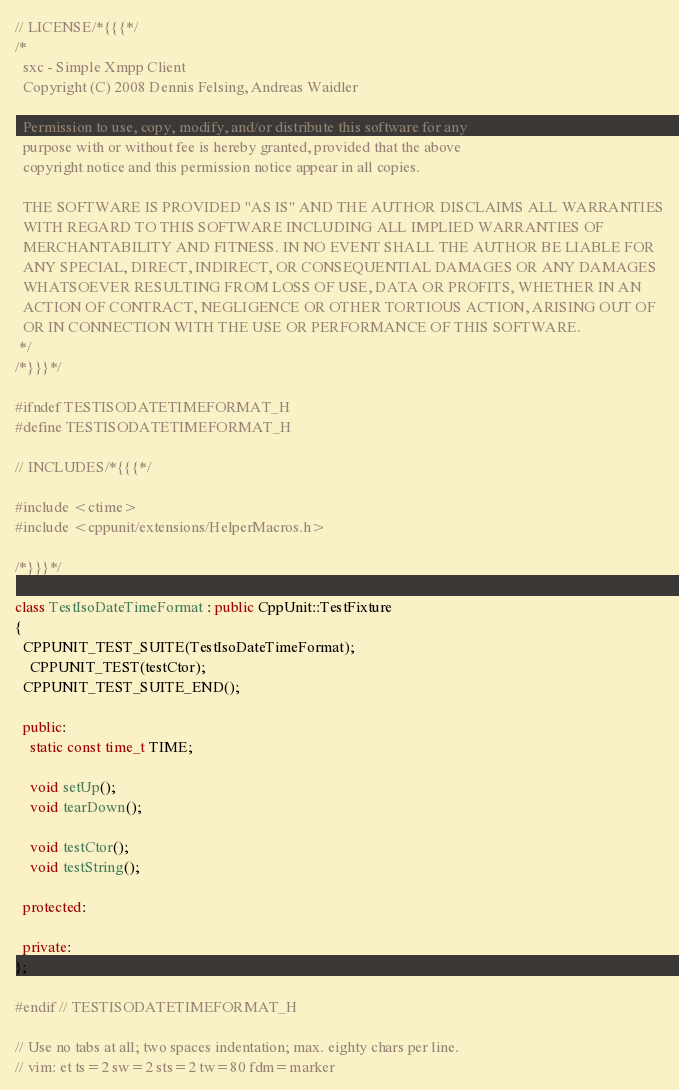<code> <loc_0><loc_0><loc_500><loc_500><_C++_>// LICENSE/*{{{*/
/*
  sxc - Simple Xmpp Client
  Copyright (C) 2008 Dennis Felsing, Andreas Waidler

  Permission to use, copy, modify, and/or distribute this software for any
  purpose with or without fee is hereby granted, provided that the above
  copyright notice and this permission notice appear in all copies.

  THE SOFTWARE IS PROVIDED "AS IS" AND THE AUTHOR DISCLAIMS ALL WARRANTIES
  WITH REGARD TO THIS SOFTWARE INCLUDING ALL IMPLIED WARRANTIES OF
  MERCHANTABILITY AND FITNESS. IN NO EVENT SHALL THE AUTHOR BE LIABLE FOR
  ANY SPECIAL, DIRECT, INDIRECT, OR CONSEQUENTIAL DAMAGES OR ANY DAMAGES
  WHATSOEVER RESULTING FROM LOSS OF USE, DATA OR PROFITS, WHETHER IN AN
  ACTION OF CONTRACT, NEGLIGENCE OR OTHER TORTIOUS ACTION, ARISING OUT OF
  OR IN CONNECTION WITH THE USE OR PERFORMANCE OF THIS SOFTWARE.
 */
/*}}}*/

#ifndef TESTISODATETIMEFORMAT_H
#define TESTISODATETIMEFORMAT_H

// INCLUDES/*{{{*/

#include <ctime>
#include <cppunit/extensions/HelperMacros.h>

/*}}}*/

class TestIsoDateTimeFormat : public CppUnit::TestFixture
{
  CPPUNIT_TEST_SUITE(TestIsoDateTimeFormat);
    CPPUNIT_TEST(testCtor);
  CPPUNIT_TEST_SUITE_END();

  public:
    static const time_t TIME;

    void setUp();
    void tearDown();

    void testCtor();
    void testString();

  protected:

  private:
};

#endif // TESTISODATETIMEFORMAT_H

// Use no tabs at all; two spaces indentation; max. eighty chars per line.
// vim: et ts=2 sw=2 sts=2 tw=80 fdm=marker
</code> 